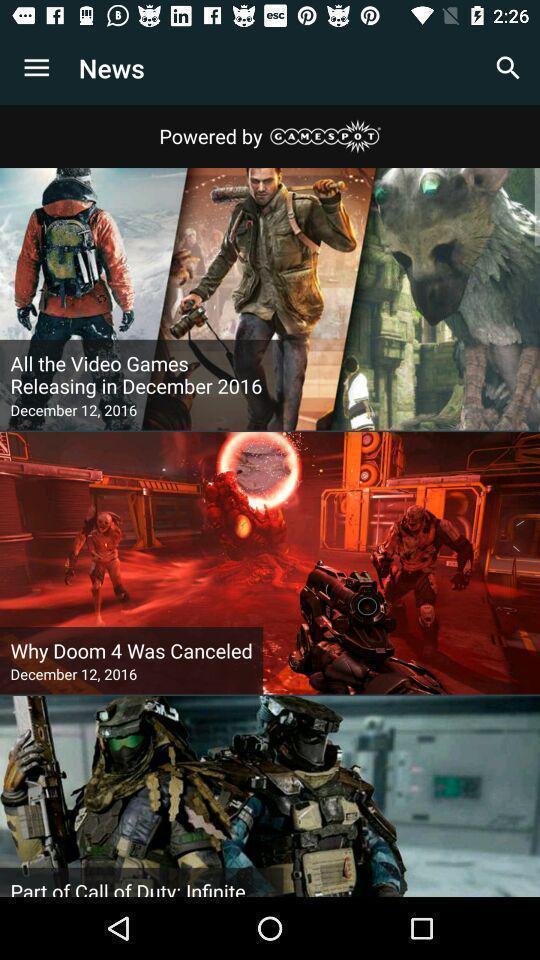Tell me about the visual elements in this screen capture. Screens shows different news in a news app. 